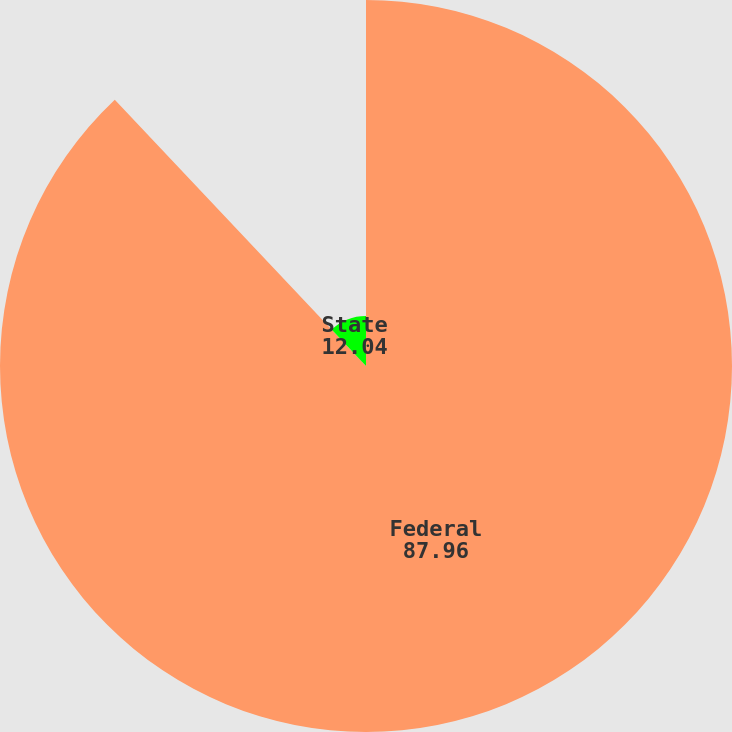Convert chart to OTSL. <chart><loc_0><loc_0><loc_500><loc_500><pie_chart><fcel>Federal<fcel>State<nl><fcel>87.96%<fcel>12.04%<nl></chart> 